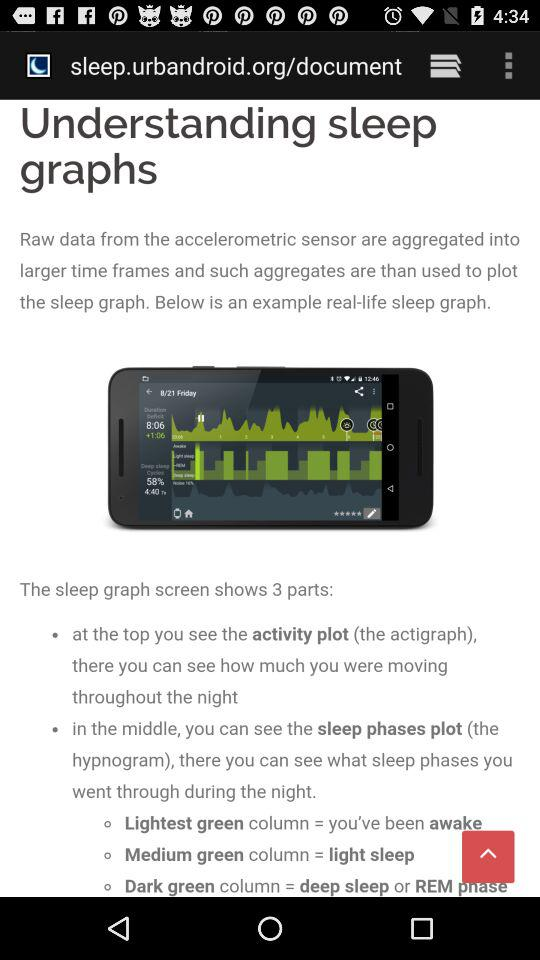Which thing does the sleep graph's lightest green column indicate? The sleep graph's lightest green column indicates that you've been awake. 